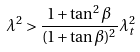Convert formula to latex. <formula><loc_0><loc_0><loc_500><loc_500>\lambda ^ { 2 } > \frac { 1 + \tan ^ { 2 } \beta } { ( 1 + \tan { \beta } ) ^ { 2 } } \lambda _ { t } ^ { 2 }</formula> 